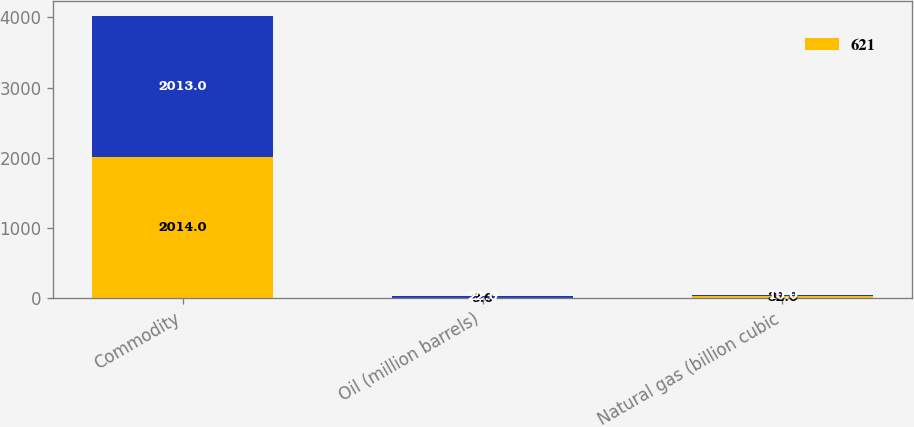<chart> <loc_0><loc_0><loc_500><loc_500><stacked_bar_chart><ecel><fcel>Commodity<fcel>Oil (million barrels)<fcel>Natural gas (billion cubic<nl><fcel>621<fcel>2014<fcel>9<fcel>32<nl><fcel>nan<fcel>2013<fcel>22<fcel>10<nl></chart> 